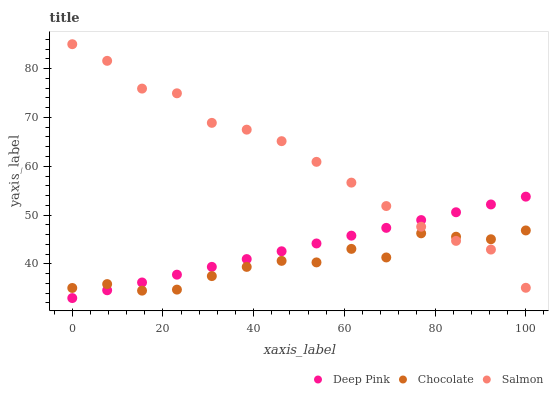Does Chocolate have the minimum area under the curve?
Answer yes or no. Yes. Does Salmon have the maximum area under the curve?
Answer yes or no. Yes. Does Salmon have the minimum area under the curve?
Answer yes or no. No. Does Chocolate have the maximum area under the curve?
Answer yes or no. No. Is Deep Pink the smoothest?
Answer yes or no. Yes. Is Chocolate the roughest?
Answer yes or no. Yes. Is Salmon the smoothest?
Answer yes or no. No. Is Salmon the roughest?
Answer yes or no. No. Does Deep Pink have the lowest value?
Answer yes or no. Yes. Does Chocolate have the lowest value?
Answer yes or no. No. Does Salmon have the highest value?
Answer yes or no. Yes. Does Chocolate have the highest value?
Answer yes or no. No. Does Chocolate intersect Deep Pink?
Answer yes or no. Yes. Is Chocolate less than Deep Pink?
Answer yes or no. No. Is Chocolate greater than Deep Pink?
Answer yes or no. No. 